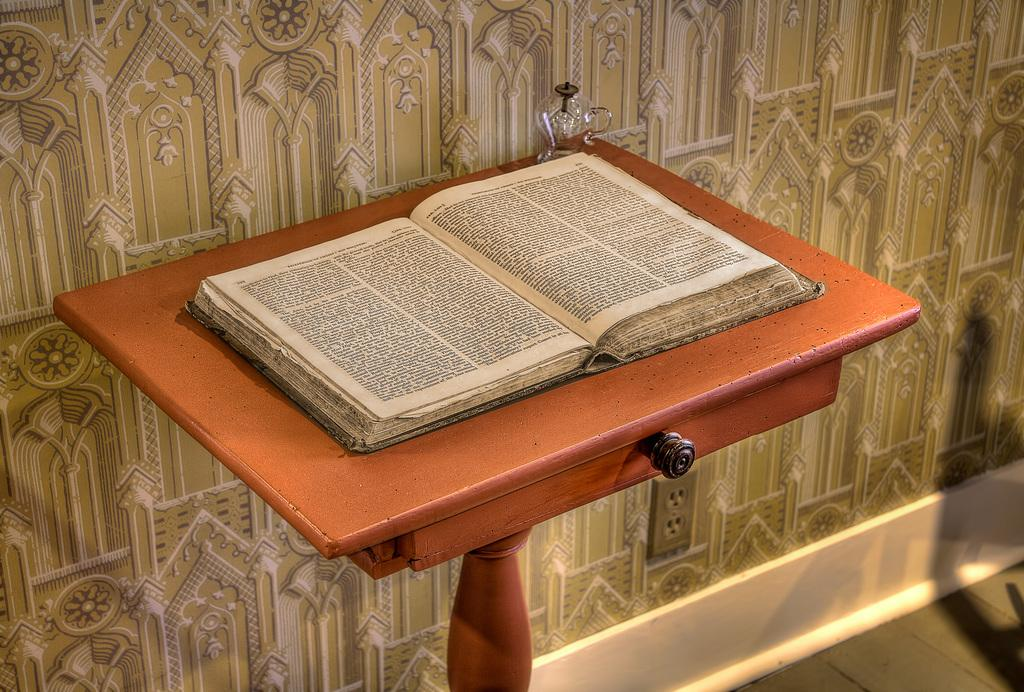What is the main object in the image? There is a book opened in the image. Where is the book placed? The book is kept on a wooden table. What can be seen on the wall in the background of the image? There is a pattern on the wall in the background of the image. What is fixed to the wall in the background of the image? A socket is fixed to the wall in the background of the image. How many frogs are sitting on the book in the image? There are no frogs present in the image; the book is the main object. What type of soup is being prepared in the image? There is no soup or cooking activity depicted in the image. 